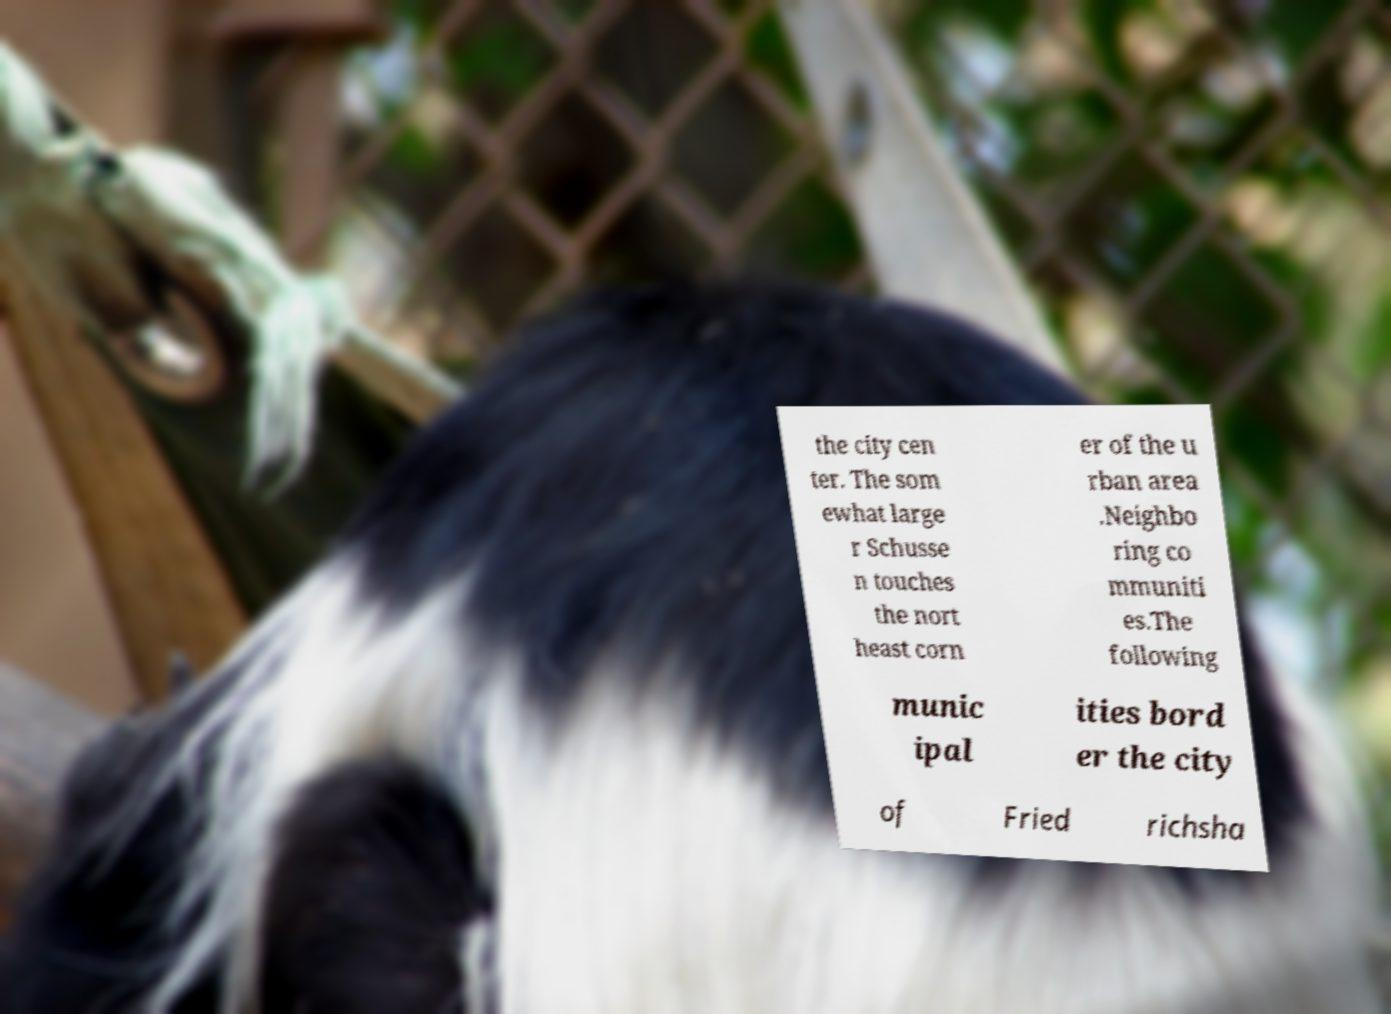I need the written content from this picture converted into text. Can you do that? the city cen ter. The som ewhat large r Schusse n touches the nort heast corn er of the u rban area .Neighbo ring co mmuniti es.The following munic ipal ities bord er the city of Fried richsha 